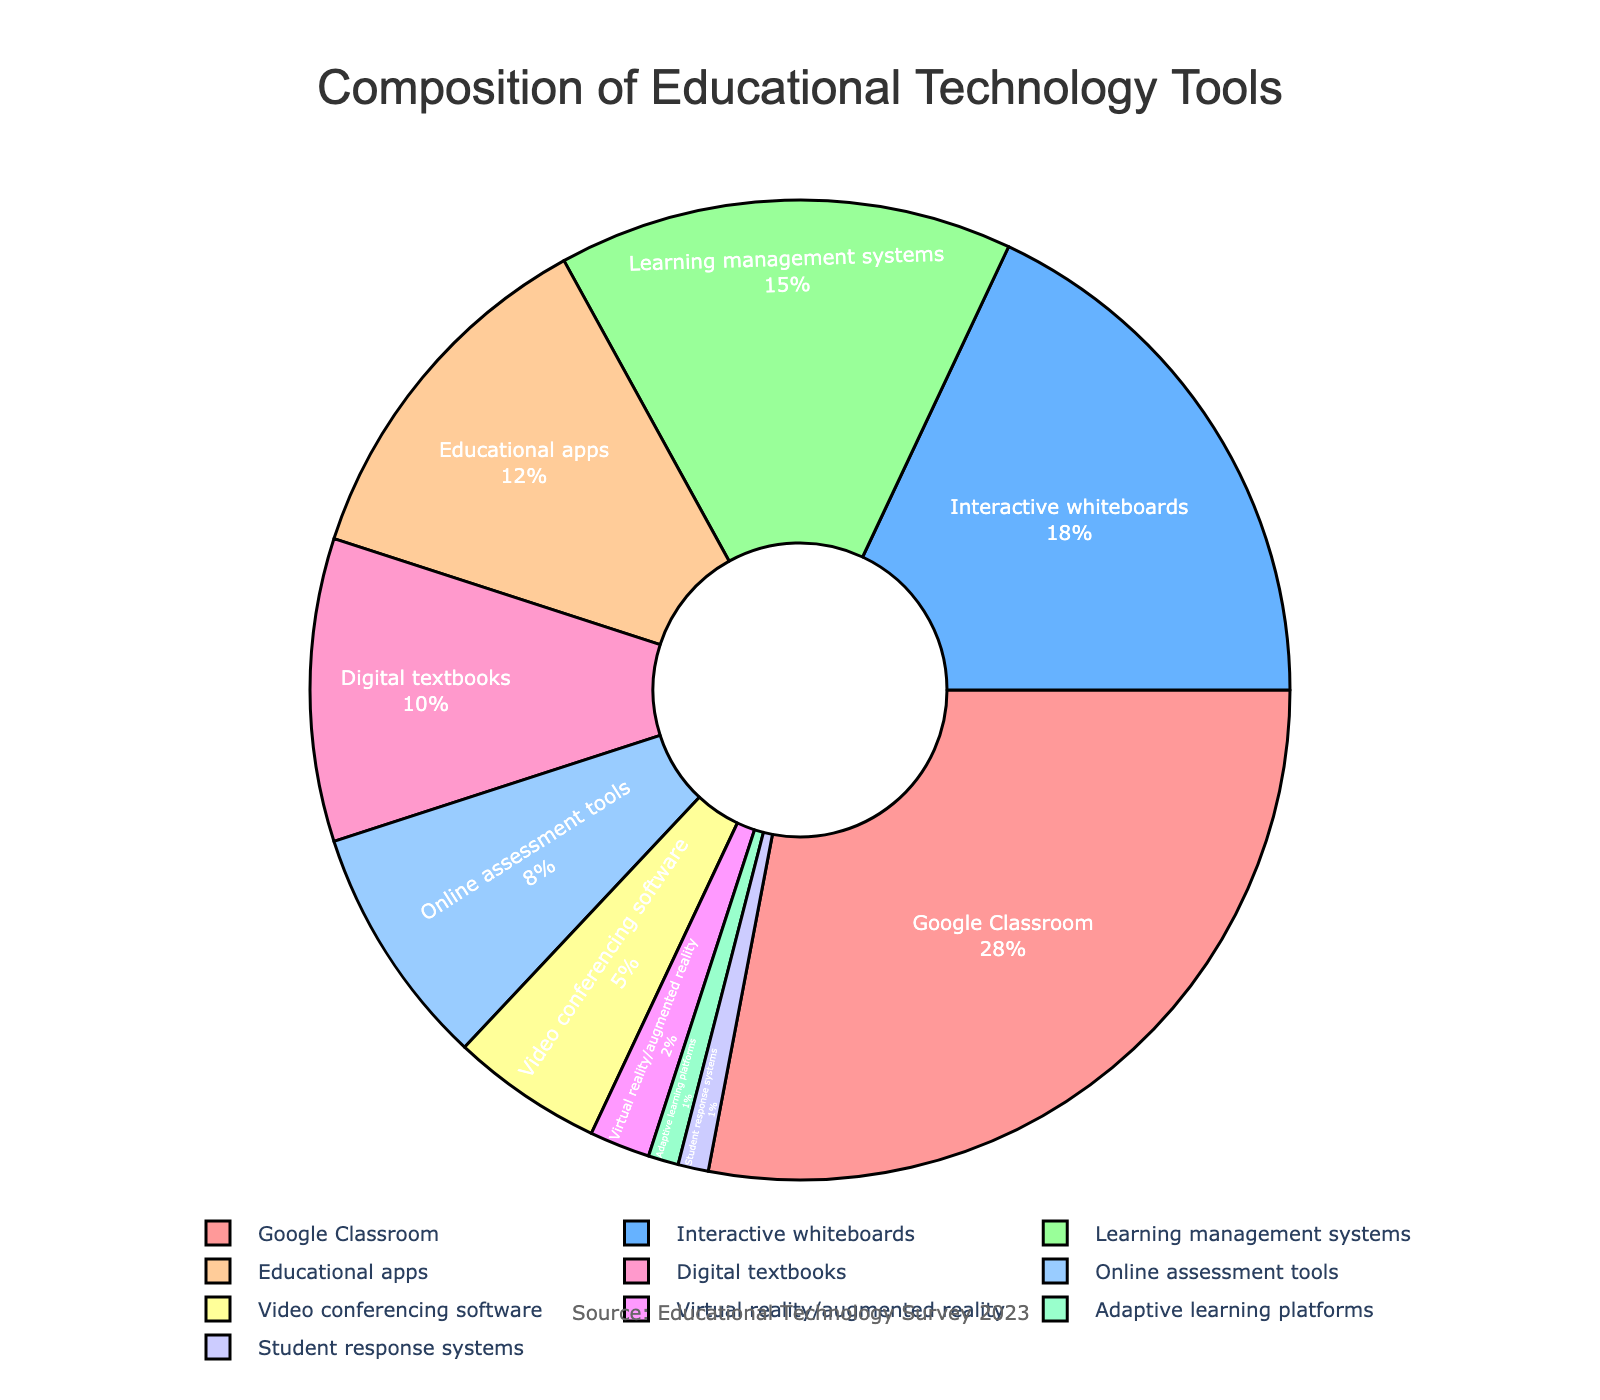What's the most used educational technology tool in classrooms? To determine the most used educational technology tool, we look for the segment with the largest percentage. According to the data in the pie chart, Google Classroom occupies the largest segment with 28%.
Answer: Google Classroom Which tool is used less frequently: Online assessment tools or Digital textbooks? We compare the percentage values of Online assessment tools and Digital textbooks. Online assessment tools have 8% while Digital textbooks have 10%. Since 8% is less than 10%, Online assessment tools are used less frequently.
Answer: Online assessment tools What is the combined percentage of use for Interactive whiteboards and Learning management systems? To find the combined percentage, we add the percentages of Interactive whiteboards and Learning management systems. Interactive whiteboards have 18% and Learning management systems have 15%, resulting in a combined total of 18% + 15% = 33%.
Answer: 33% Which tool has the lowest usage percentage, and what is it? We look for the smallest segment in the pie chart. Both Adaptive learning platforms and Student response systems each have the lowest usage percentage of 1%.
Answer: Adaptive learning platforms and Student response systems How much larger is the percentage of Google Classroom usage compared to that of Video conferencing software? To determine how much larger the usage of Google Classroom is compared to Video conferencing software, we calculate the difference between their percentages. Google Classroom has 28% while Video conferencing software has 5%. The difference is 28% - 5% = 23%.
Answer: 23% What is the average usage percentage for Educational apps, Digital textbooks, and Online assessment tools? To calculate the average usage percentage, we sum the percentages of Educational apps, Digital textbooks, and Online assessment tools, and then divide by the number of tools. Educational apps have 12%, Digital textbooks have 10%, and Online assessment tools have 8%. The sum is 12% + 10% + 8% = 30%. There are 3 tools, so the average is 30% / 3 = 10%.
Answer: 10% Which tool is visually represented with the color used for the third largest segment in the chart? To identify this, we find the third largest percentage by sorting the values: Google Classroom (28%), Interactive whiteboards (18%), and Learning management systems (15%). Therefore, Learning management systems, which have 15%, are visually represented by the color of the third largest segment. Verify the color in the visual element for precision.
Answer: Learning management systems What's the difference in usage percentage between the most and least used tools? The most used tool is Google Classroom with 28%, and the least used tools are Adaptive learning platforms and Student response systems each with 1%. The difference is 28% - 1% = 27%.
Answer: 27% If you combine the usage of Virtual reality/augmented reality and Adaptive learning platforms, how does the total compare to the usage of Educational apps? First, we sum the percentages of Virtual reality/augmented reality and Adaptive learning platforms: 2% + 1% = 3%. Then, we compare this total to the usage of Educational apps which is 12%. Since 3% is less than 12%, the combined usage is significantly lower.
Answer: 3% < 12% 